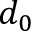Convert formula to latex. <formula><loc_0><loc_0><loc_500><loc_500>d _ { 0 }</formula> 